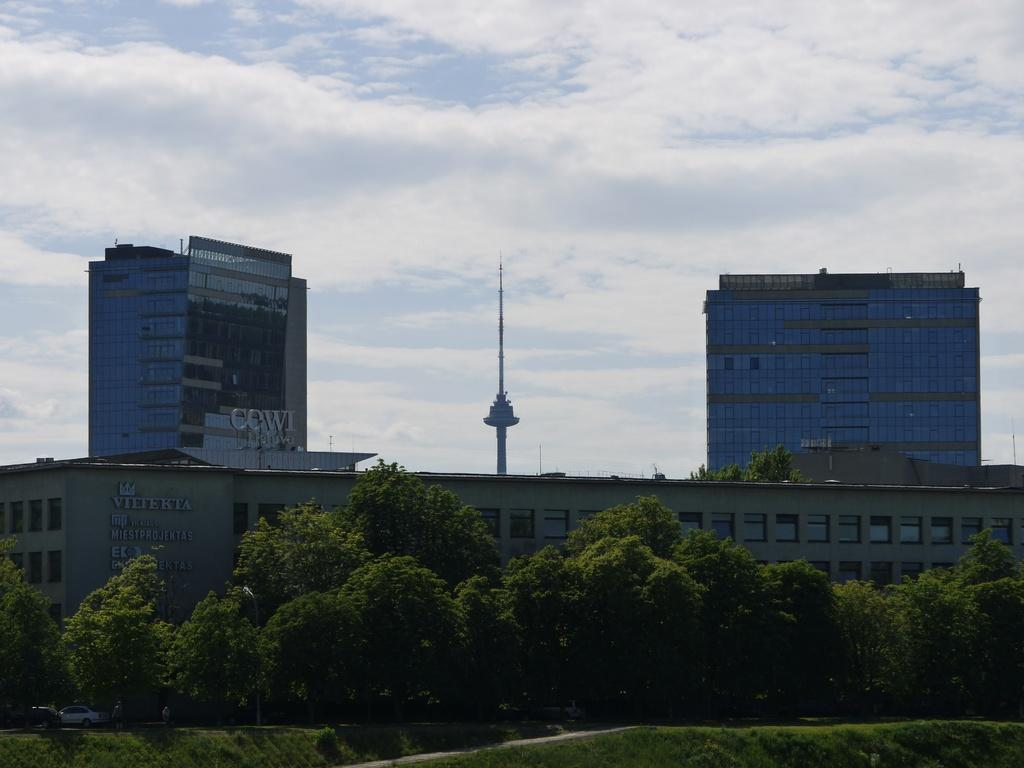What is visible in the foreground of the picture? There are trees and grass in the foreground of the picture. What can be seen in the center of the picture? There are buildings and trees in the center of the picture. What is the background of the image? The background of the image is the sky. What is the condition of the sky in the picture? The sky is cloudy in the picture. Can you tell me where the shop is located in the image? There is no shop mentioned or visible in the image. How many girls are present in the image? There is no girl mentioned or visible in the image. 